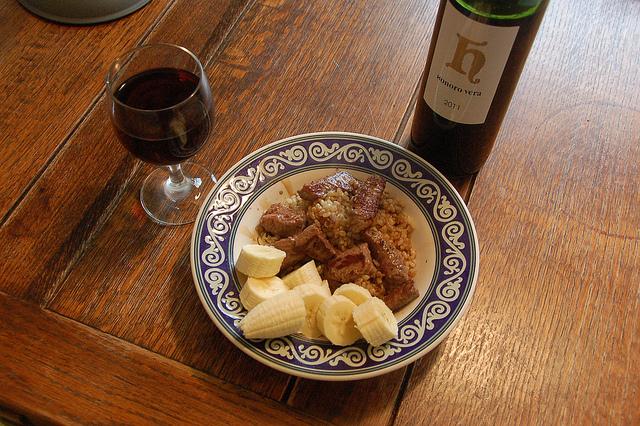Is there a tablecloth on the table?
Be succinct. No. What fruit is in the bowl?
Answer briefly. Banana. What is cut up in the bowl?
Keep it brief. Banana. What is in the clear cup?
Write a very short answer. Wine. 